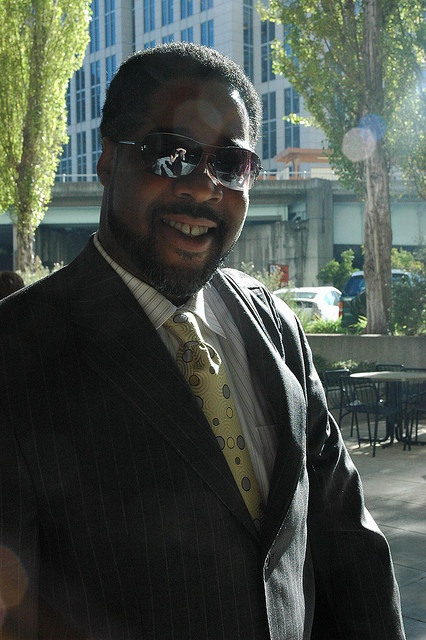Describe the objects in this image and their specific colors. I can see people in black, khaki, gray, darkgray, and white tones, tie in khaki, black, darkgreen, gray, and white tones, chair in khaki, black, gray, purple, and darkgray tones, car in khaki, white, darkgray, beige, and olive tones, and chair in khaki, black, gray, and purple tones in this image. 